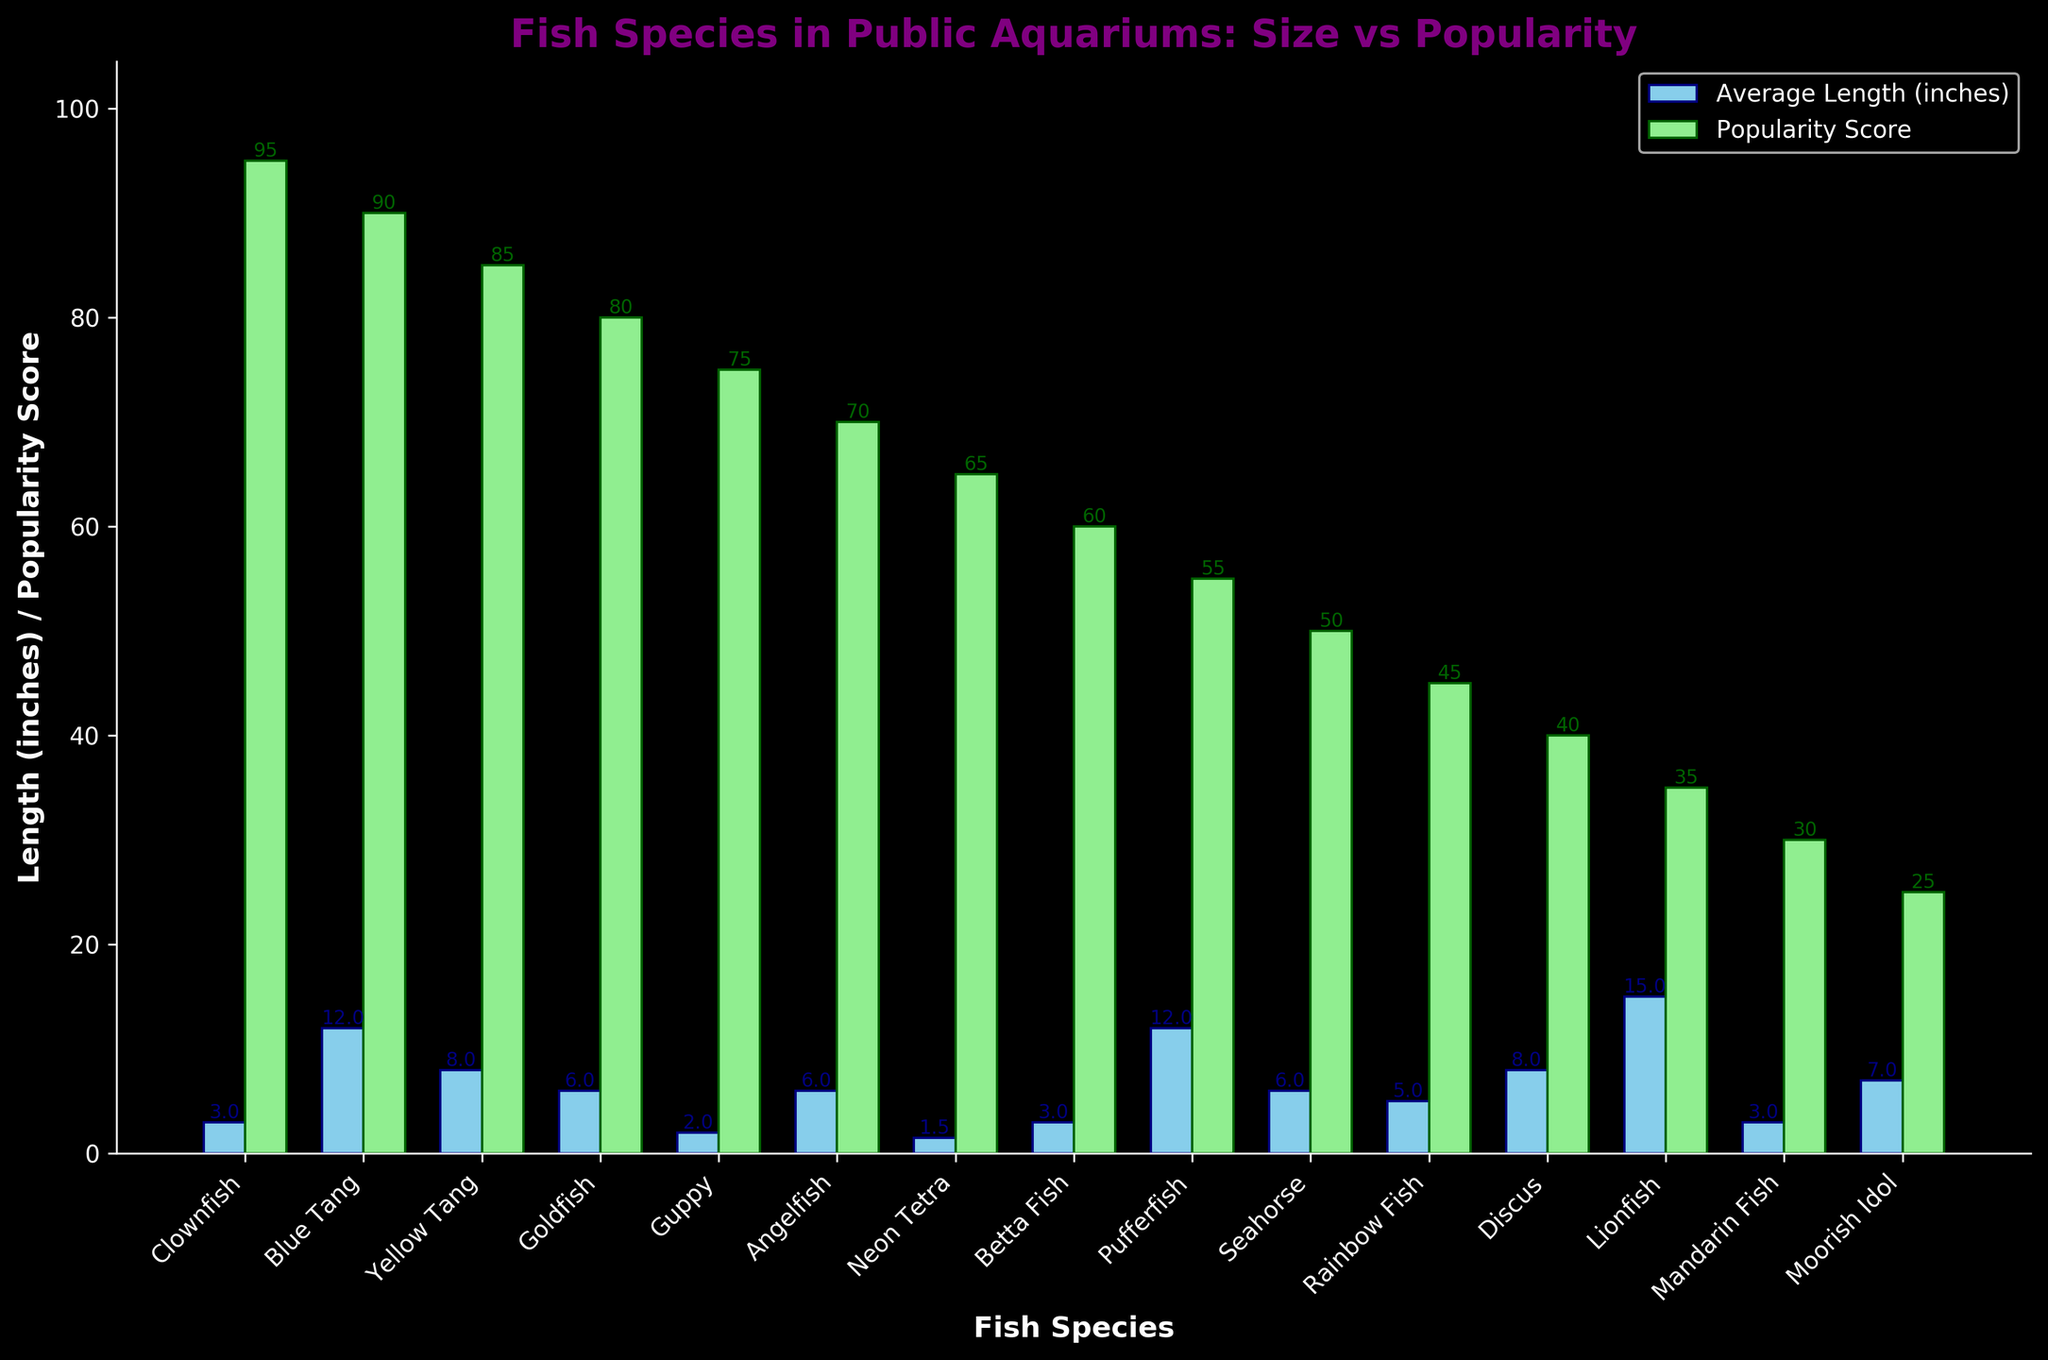What fish species has the highest popularity score? Look for the bar that represents the popularity score and has the greatest height. The Clownfish bar is the tallest in the popularity category.
Answer: Clownfish Which fish species are the longest and shortest on average? Compare the height of the bars representing average length. The Lionfish has the tallest bar for length, and the Neon Tetra has the shortest.
Answer: Lionfish (longest), Neon Tetra (shortest) What is the difference in popularity score between the Clownfish and the Mandarin Fish? Find the popularity scores of Clownfish (95) and Mandarin Fish (30), then calculate the difference 95 - 30 = 65.
Answer: 65 How many fish species have an average length greater than 10 inches? Count the bars in the average length category that are taller than 10 inches. Blue Tang, Pufferfish, and Lionfish are longer than 10 inches.
Answer: 3 Which fish species has exactly the same value for both average length and popularity score? Identify the bars where both average length and popularity score are equal in height; none of the species has the same value for both variables.
Answer: None Which fish species has the smallest difference between average length and popularity score? Find the absolute differences between the lengths and popularity scores for each species and identify the smallest difference. Clownfish and Guppy have a difference of 2 (95-3=92). The smallest difference is for Goldfish (80-6=74).
Answer: Goldfish What is the average popularity score of all fish species? Sum all the popularity scores (95+90+85+80+75+70+65+60+55+50+45+40+35+30+25) = 900. Divide by the number of species (15). 900/15 = 60.
Answer: 60 Which fish species has a higher popularity score: Yellow Tang or Angelfish? Compare the heights of the popularity bars for Yellow Tang (85) and Angelfish (70).
Answer: Yellow Tang Does the Pufferfish have a higher average length or a higher popularity score? Compare the bar heights for the Pufferfish in both average length (12 inches) and popularity score (55).
Answer: Higher average length 